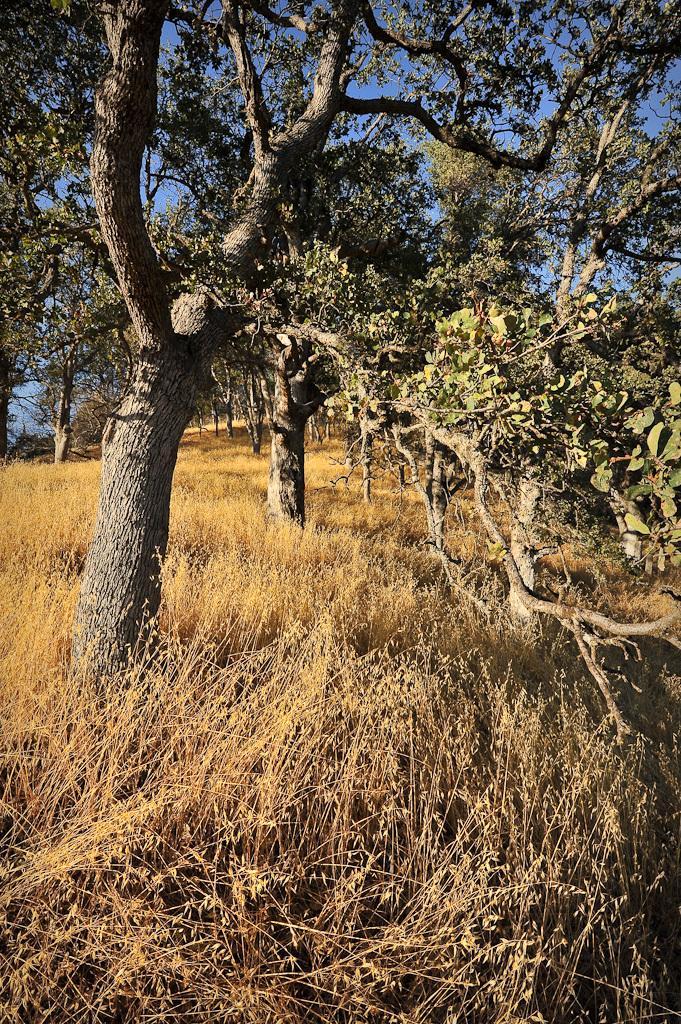Describe this image in one or two sentences. In the center of the image there are trees. At the bottom of the image there is grass. 